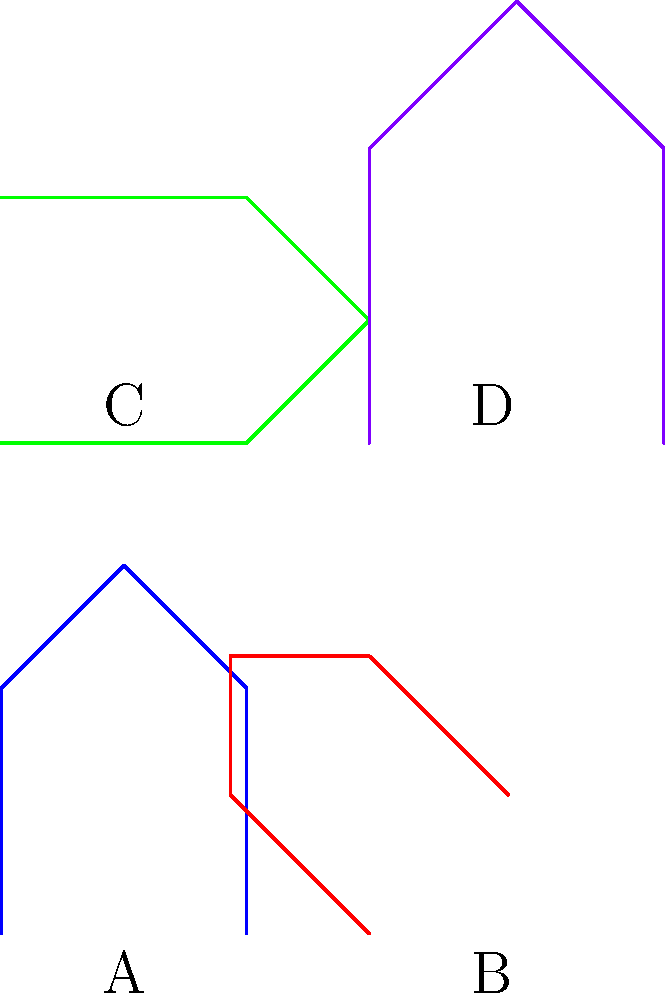As a streamer showcasing bug-free gameplay, you need to ensure that character models are consistent across different poses. Which two character models in the diagram are congruent, meaning they have the same shape and size but may be in different positions or orientations? To determine which character models are congruent, we need to analyze their shape and size, regardless of their position or orientation. Let's examine each model:

1. Model A (blue): This is our reference model.

2. Model B (red): This model appears to be a rotated and slightly scaled-down version of Model A. The rotation is approximately 45 degrees, and the scaling factor is about 0.8. Since the size is different, it is not congruent to Model A.

3. Model C (green): This model is a reflection of Model A across the line y=x. Reflection preserves both shape and size, so Model C is congruent to Model A.

4. Model D (purple): This model is an enlarged version of Model A, with a scaling factor of about 1.2. Since the size is different, it is not congruent to Model A.

By comparing all models, we can conclude that Models A and C are congruent to each other, as they have the same shape and size, differing only in orientation due to the reflection.
Answer: A and C 